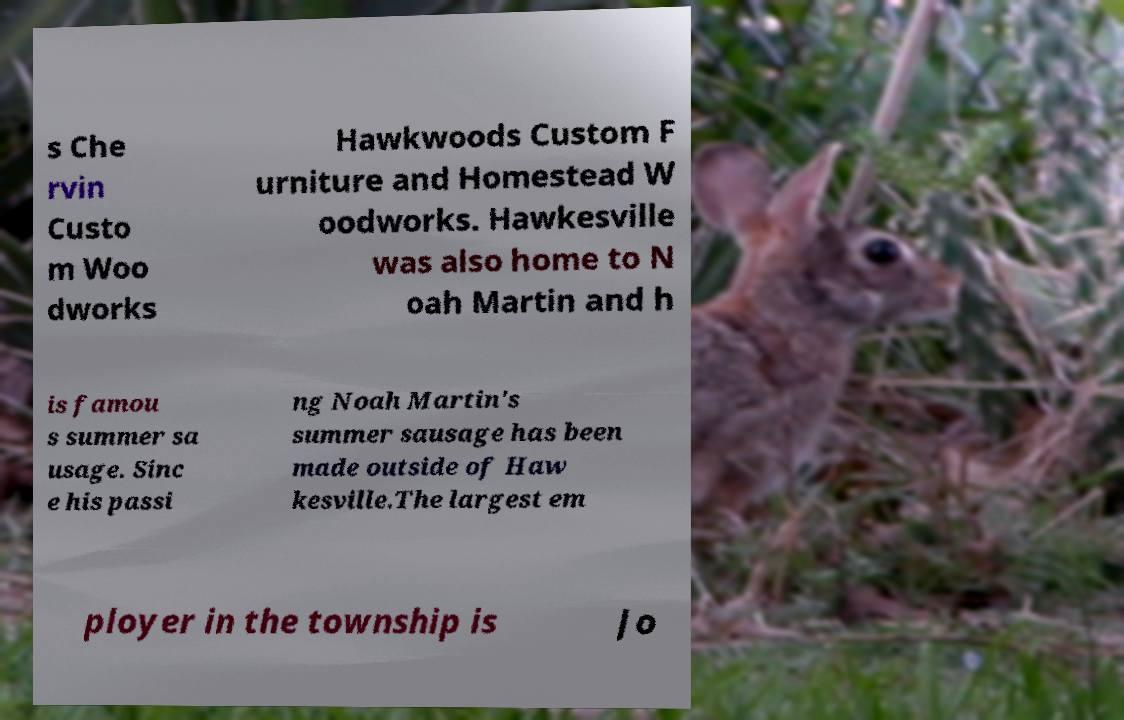What messages or text are displayed in this image? I need them in a readable, typed format. s Che rvin Custo m Woo dworks Hawkwoods Custom F urniture and Homestead W oodworks. Hawkesville was also home to N oah Martin and h is famou s summer sa usage. Sinc e his passi ng Noah Martin's summer sausage has been made outside of Haw kesville.The largest em ployer in the township is Jo 